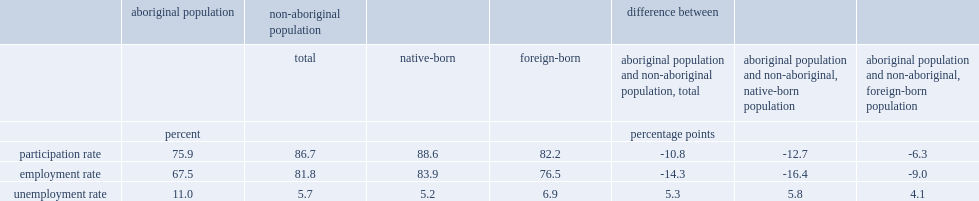In 2015, what was the percentage points of the disparity in employment rates between aboriginal and non-aboriginal people when the foreign-born were excluded from the non-aboriginal population? 16.4. In 2015, what was the percentage points of the disparity in employment rates between aboriginal and non-aboriginal people when the foreign-born were included from the non-aboriginal population? 14.3. 